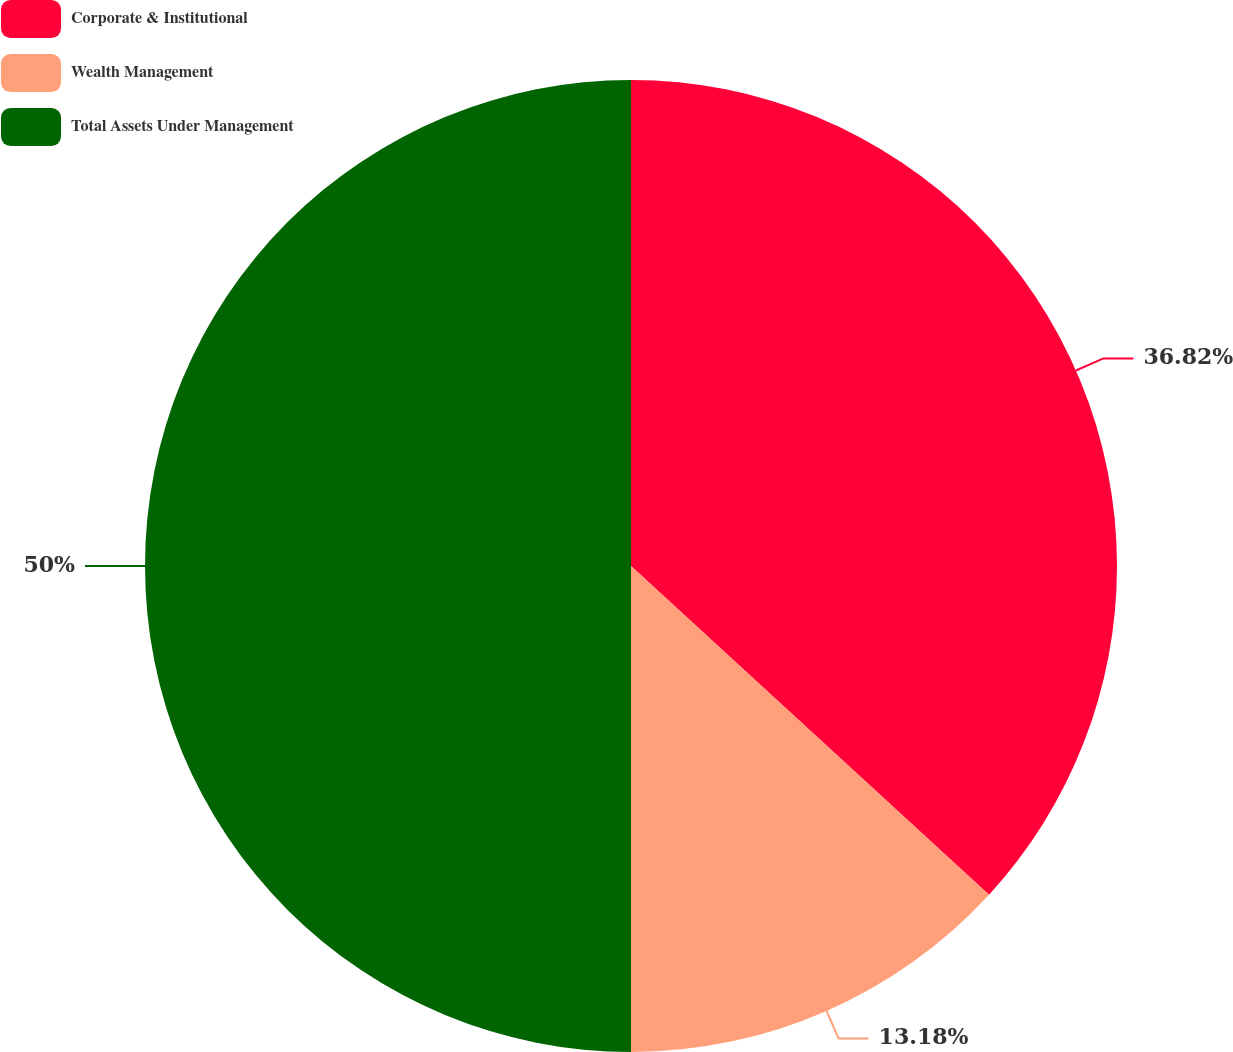Convert chart to OTSL. <chart><loc_0><loc_0><loc_500><loc_500><pie_chart><fcel>Corporate & Institutional<fcel>Wealth Management<fcel>Total Assets Under Management<nl><fcel>36.82%<fcel>13.18%<fcel>50.0%<nl></chart> 